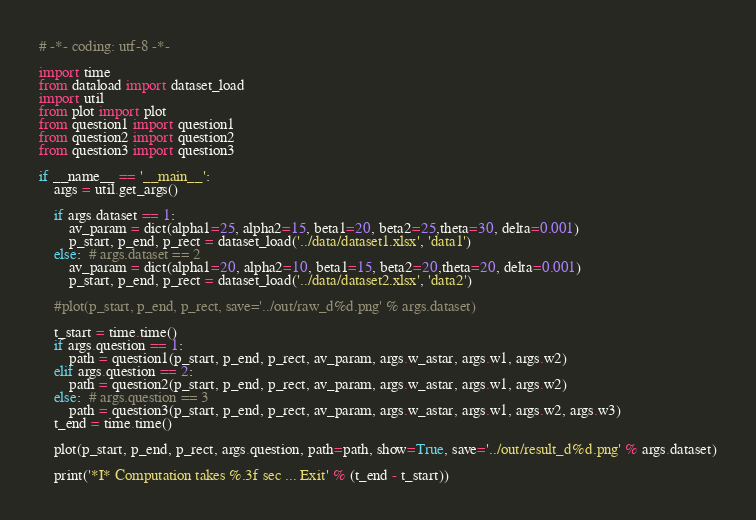<code> <loc_0><loc_0><loc_500><loc_500><_Python_># -*- coding: utf-8 -*-

import time
from dataload import dataset_load
import util
from plot import plot
from question1 import question1
from question2 import question2
from question3 import question3

if __name__ == '__main__':
    args = util.get_args()

    if args.dataset == 1:
        av_param = dict(alpha1=25, alpha2=15, beta1=20, beta2=25,theta=30, delta=0.001)
        p_start, p_end, p_rect = dataset_load('../data/dataset1.xlsx', 'data1')
    else:  # args.dataset == 2
        av_param = dict(alpha1=20, alpha2=10, beta1=15, beta2=20,theta=20, delta=0.001)
        p_start, p_end, p_rect = dataset_load('../data/dataset2.xlsx', 'data2')

    #plot(p_start, p_end, p_rect, save='../out/raw_d%d.png' % args.dataset)

    t_start = time.time()
    if args.question == 1:
        path = question1(p_start, p_end, p_rect, av_param, args.w_astar, args.w1, args.w2)
    elif args.question == 2:
        path = question2(p_start, p_end, p_rect, av_param, args.w_astar, args.w1, args.w2)
    else:  # args.question == 3
        path = question3(p_start, p_end, p_rect, av_param, args.w_astar, args.w1, args.w2, args.w3)
    t_end = time.time()

    plot(p_start, p_end, p_rect, args.question, path=path, show=True, save='../out/result_d%d.png' % args.dataset)

    print('*I* Computation takes %.3f sec ... Exit' % (t_end - t_start))
</code> 